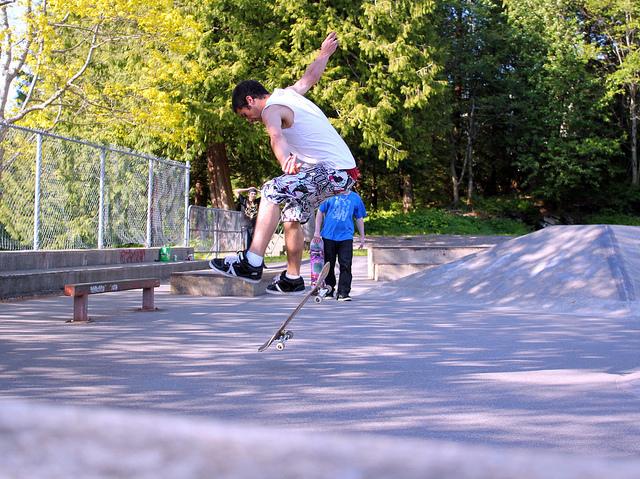Does the fence have a gate?
Give a very brief answer. Yes. What are these people riding?
Write a very short answer. Skateboard. Are the feet of the man in the yellow shirt touching the skateboard?
Concise answer only. No. What is the man doing?
Quick response, please. Skateboarding. 